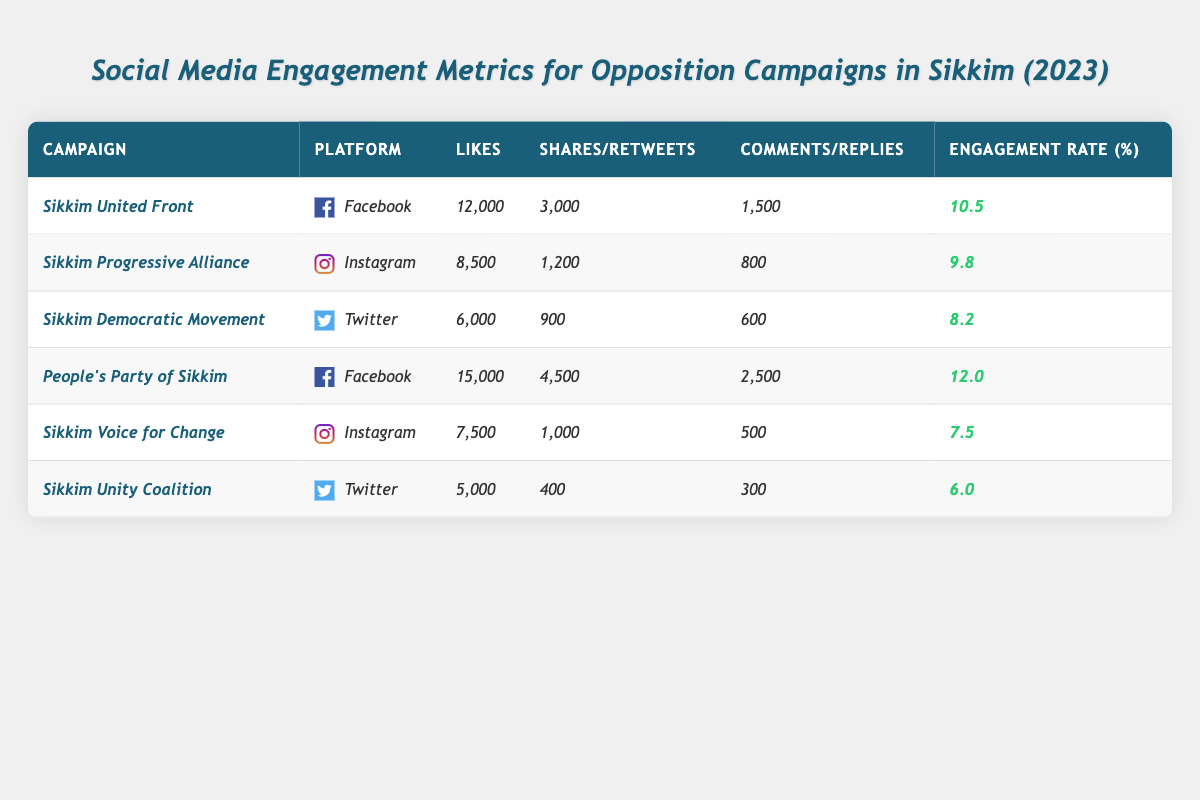What is the total number of Likes on Facebook campaigns? The Facebook campaigns in the table are by "Sikkim United Front" and "People's Party of Sikkim," with Likes of 12,000 and 15,000 respectively. Summing these gives 12,000 + 15,000 = 27,000 Likes.
Answer: 27,000 Which campaign had the highest Engagement Rate? Looking at the Engagement Rate column, "People's Party of Sikkim" has the highest rate at 12.0%.
Answer: 12.0% How many Likes did the "Sikkim Democratic Movement" receive? Referring to the data, the "Sikkim Democratic Movement" received 6,000 Likes.
Answer: 6,000 What is the Engagement Rate for the "Sikkim Voice for Change"? The Engagement Rate for "Sikkim Voice for Change" listed in the table is 7.5%.
Answer: 7.5% Which platform had the lowest engagement for the campaigns listed? Comparing Engagement Rates across all platforms, "Sikkim Unity Coalition" on Twitter has the lowest at 6.0%.
Answer: 6.0% What is the total number of Shares for the "Sikkim Progressive Alliance"? The "Sikkim Progressive Alliance" has 1,200 Shares listed in the table.
Answer: 1,200 If we consider only Facebook campaigns, what is the average Engagement Rate? The Facebook campaigns are "Sikkim United Front" (10.5%) and "People's Party of Sikkim" (12.0%). The average is calculated as (10.5 + 12.0) / 2 = 11.25%.
Answer: 11.25% Is the number of Shares for "People's Party of Sikkim" greater than that of "Sikkim United Front"? "People's Party of Sikkim" has 4,500 Shares, while "Sikkim United Front" has 3,000 Shares. Since 4,500 is greater than 3,000, the statement is true.
Answer: Yes What is the difference in Likes between the highest and lowest campaigns? The highest Likes are from "People's Party of Sikkim" with 15,000 and the lowest from "Sikkim Unity Coalition" with 5,000. The difference is 15,000 - 5,000 = 10,000.
Answer: 10,000 How many total Comments were made for all campaigns on Instagram? The Instagram campaigns "Sikkim Progressive Alliance" and "Sikkim Voice for Change" received 800 and 500 Comments respectively. Summing these gives 800 + 500 = 1,300 Comments.
Answer: 1,300 